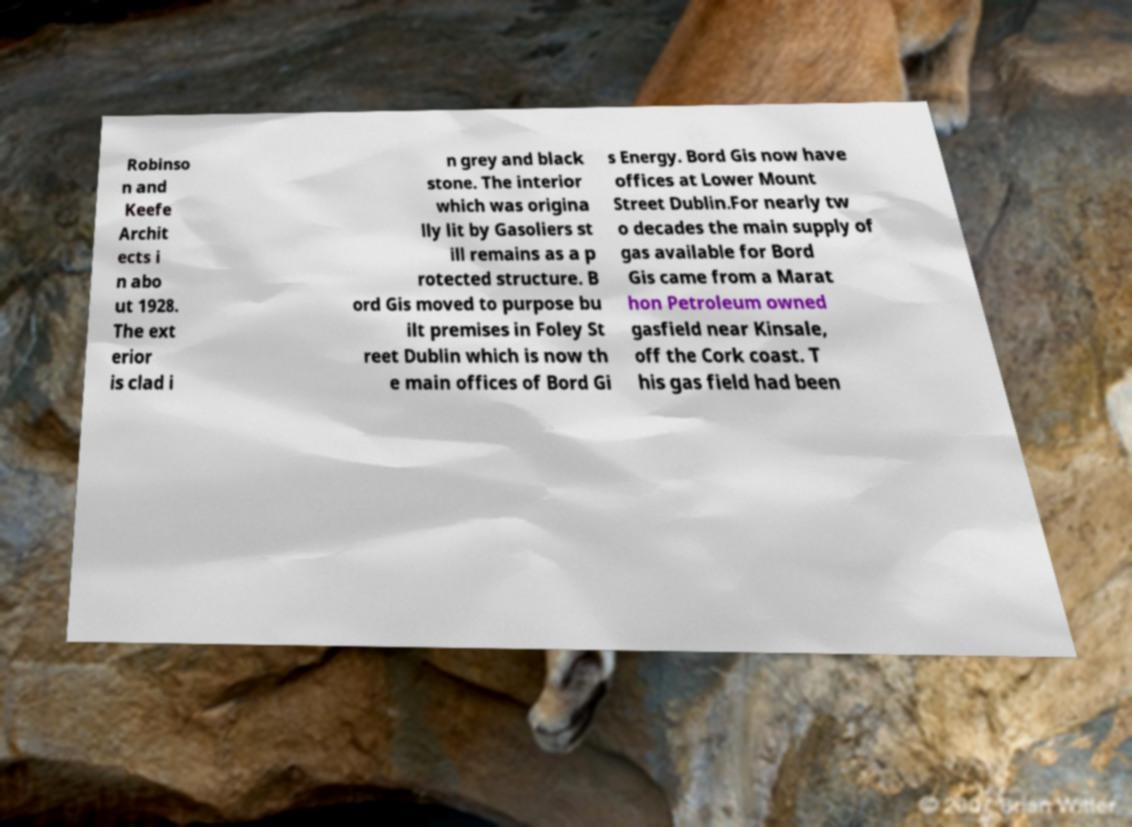Can you accurately transcribe the text from the provided image for me? Robinso n and Keefe Archit ects i n abo ut 1928. The ext erior is clad i n grey and black stone. The interior which was origina lly lit by Gasoliers st ill remains as a p rotected structure. B ord Gis moved to purpose bu ilt premises in Foley St reet Dublin which is now th e main offices of Bord Gi s Energy. Bord Gis now have offices at Lower Mount Street Dublin.For nearly tw o decades the main supply of gas available for Bord Gis came from a Marat hon Petroleum owned gasfield near Kinsale, off the Cork coast. T his gas field had been 